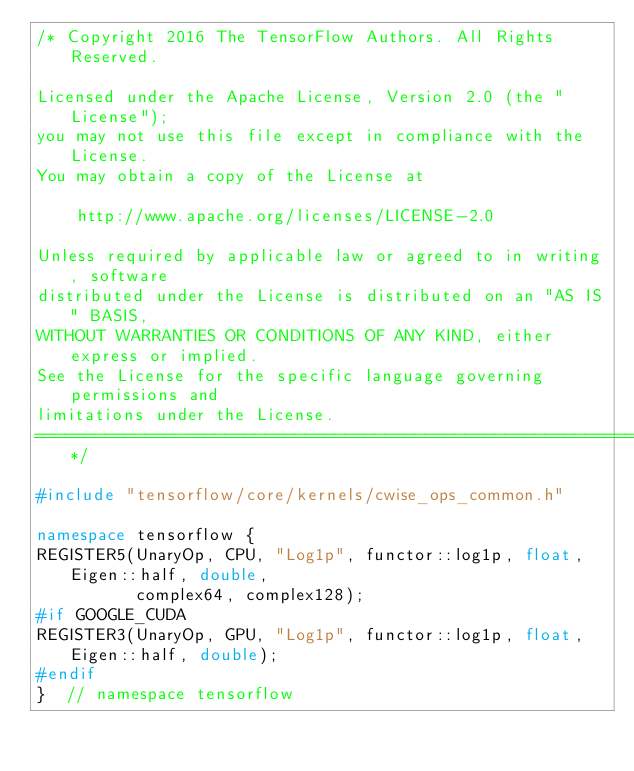<code> <loc_0><loc_0><loc_500><loc_500><_C++_>/* Copyright 2016 The TensorFlow Authors. All Rights Reserved.

Licensed under the Apache License, Version 2.0 (the "License");
you may not use this file except in compliance with the License.
You may obtain a copy of the License at

    http://www.apache.org/licenses/LICENSE-2.0

Unless required by applicable law or agreed to in writing, software
distributed under the License is distributed on an "AS IS" BASIS,
WITHOUT WARRANTIES OR CONDITIONS OF ANY KIND, either express or implied.
See the License for the specific language governing permissions and
limitations under the License.
==============================================================================*/

#include "tensorflow/core/kernels/cwise_ops_common.h"

namespace tensorflow {
REGISTER5(UnaryOp, CPU, "Log1p", functor::log1p, float, Eigen::half, double,
          complex64, complex128);
#if GOOGLE_CUDA
REGISTER3(UnaryOp, GPU, "Log1p", functor::log1p, float, Eigen::half, double);
#endif
}  // namespace tensorflow
</code> 